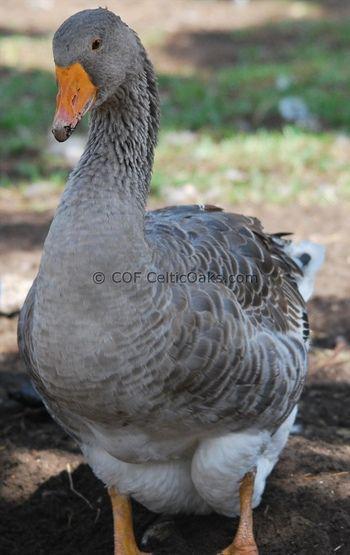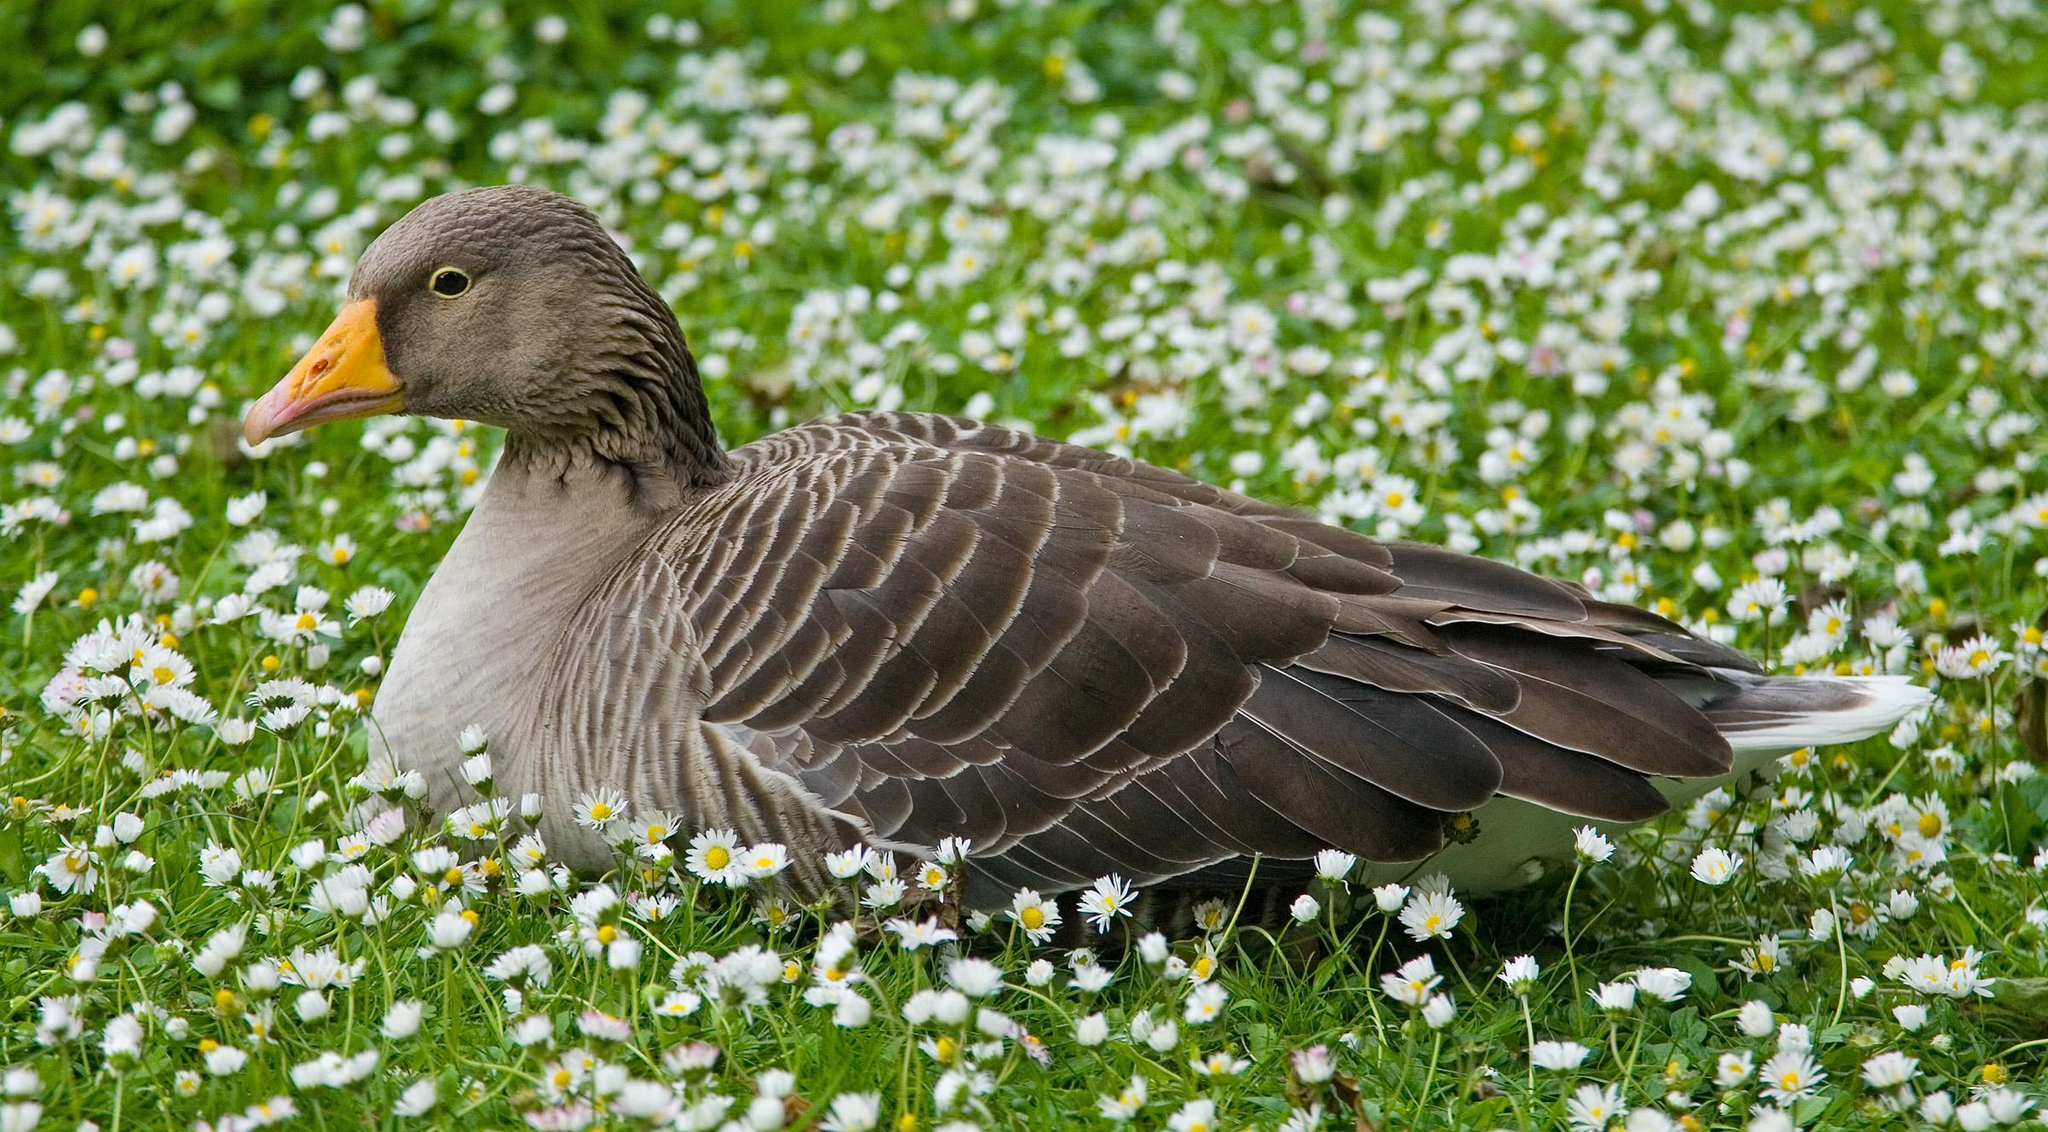The first image is the image on the left, the second image is the image on the right. Considering the images on both sides, is "the goose on the right image is facing right" valid? Answer yes or no. No. 